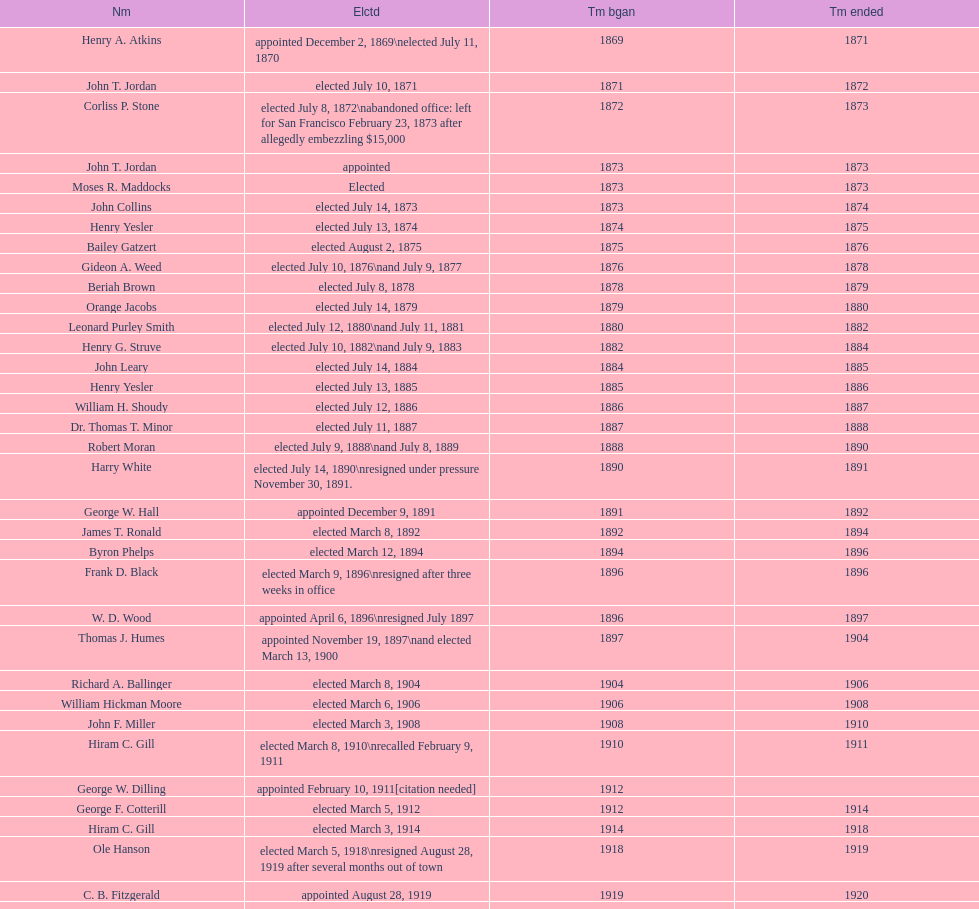Who began their term in 1890? Harry White. I'm looking to parse the entire table for insights. Could you assist me with that? {'header': ['Nm', 'Elctd', 'Tm bgan', 'Tm ended'], 'rows': [['Henry A. Atkins', 'appointed December 2, 1869\\nelected July 11, 1870', '1869', '1871'], ['John T. Jordan', 'elected July 10, 1871', '1871', '1872'], ['Corliss P. Stone', 'elected July 8, 1872\\nabandoned office: left for San Francisco February 23, 1873 after allegedly embezzling $15,000', '1872', '1873'], ['John T. Jordan', 'appointed', '1873', '1873'], ['Moses R. Maddocks', 'Elected', '1873', '1873'], ['John Collins', 'elected July 14, 1873', '1873', '1874'], ['Henry Yesler', 'elected July 13, 1874', '1874', '1875'], ['Bailey Gatzert', 'elected August 2, 1875', '1875', '1876'], ['Gideon A. Weed', 'elected July 10, 1876\\nand July 9, 1877', '1876', '1878'], ['Beriah Brown', 'elected July 8, 1878', '1878', '1879'], ['Orange Jacobs', 'elected July 14, 1879', '1879', '1880'], ['Leonard Purley Smith', 'elected July 12, 1880\\nand July 11, 1881', '1880', '1882'], ['Henry G. Struve', 'elected July 10, 1882\\nand July 9, 1883', '1882', '1884'], ['John Leary', 'elected July 14, 1884', '1884', '1885'], ['Henry Yesler', 'elected July 13, 1885', '1885', '1886'], ['William H. Shoudy', 'elected July 12, 1886', '1886', '1887'], ['Dr. Thomas T. Minor', 'elected July 11, 1887', '1887', '1888'], ['Robert Moran', 'elected July 9, 1888\\nand July 8, 1889', '1888', '1890'], ['Harry White', 'elected July 14, 1890\\nresigned under pressure November 30, 1891.', '1890', '1891'], ['George W. Hall', 'appointed December 9, 1891', '1891', '1892'], ['James T. Ronald', 'elected March 8, 1892', '1892', '1894'], ['Byron Phelps', 'elected March 12, 1894', '1894', '1896'], ['Frank D. Black', 'elected March 9, 1896\\nresigned after three weeks in office', '1896', '1896'], ['W. D. Wood', 'appointed April 6, 1896\\nresigned July 1897', '1896', '1897'], ['Thomas J. Humes', 'appointed November 19, 1897\\nand elected March 13, 1900', '1897', '1904'], ['Richard A. Ballinger', 'elected March 8, 1904', '1904', '1906'], ['William Hickman Moore', 'elected March 6, 1906', '1906', '1908'], ['John F. Miller', 'elected March 3, 1908', '1908', '1910'], ['Hiram C. Gill', 'elected March 8, 1910\\nrecalled February 9, 1911', '1910', '1911'], ['George W. Dilling', 'appointed February 10, 1911[citation needed]', '1912', ''], ['George F. Cotterill', 'elected March 5, 1912', '1912', '1914'], ['Hiram C. Gill', 'elected March 3, 1914', '1914', '1918'], ['Ole Hanson', 'elected March 5, 1918\\nresigned August 28, 1919 after several months out of town', '1918', '1919'], ['C. B. Fitzgerald', 'appointed August 28, 1919', '1919', '1920'], ['Hugh M. Caldwell', 'elected March 2, 1920', '1920', '1922'], ['Edwin J. Brown', 'elected May 2, 1922\\nand March 4, 1924', '1922', '1926'], ['Bertha Knight Landes', 'elected March 9, 1926', '1926', '1928'], ['Frank E. Edwards', 'elected March 6, 1928\\nand March 4, 1930\\nrecalled July 13, 1931', '1928', '1931'], ['Robert H. Harlin', 'appointed July 14, 1931', '1931', '1932'], ['John F. Dore', 'elected March 8, 1932', '1932', '1934'], ['Charles L. Smith', 'elected March 6, 1934', '1934', '1936'], ['John F. Dore', 'elected March 3, 1936\\nbecame gravely ill and was relieved of office April 13, 1938, already a lame duck after the 1938 election. He died five days later.', '1936', '1938'], ['Arthur B. Langlie', "elected March 8, 1938\\nappointed to take office early, April 27, 1938, after Dore's death.\\nelected March 5, 1940\\nresigned January 11, 1941, to become Governor of Washington", '1938', '1941'], ['John E. Carroll', 'appointed January 27, 1941', '1941', '1941'], ['Earl Millikin', 'elected March 4, 1941', '1941', '1942'], ['William F. Devin', 'elected March 3, 1942, March 7, 1944, March 5, 1946, and March 2, 1948', '1942', '1952'], ['Allan Pomeroy', 'elected March 4, 1952', '1952', '1956'], ['Gordon S. Clinton', 'elected March 6, 1956\\nand March 8, 1960', '1956', '1964'], ["James d'Orma Braman", 'elected March 10, 1964\\nresigned March 23, 1969, to accept an appointment as an Assistant Secretary in the Department of Transportation in the Nixon administration.', '1964', '1969'], ['Floyd C. Miller', 'appointed March 23, 1969', '1969', '1969'], ['Wesley C. Uhlman', 'elected November 4, 1969\\nand November 6, 1973\\nsurvived recall attempt on July 1, 1975', 'December 1, 1969', 'January 1, 1978'], ['Charles Royer', 'elected November 8, 1977, November 3, 1981, and November 5, 1985', 'January 1, 1978', 'January 1, 1990'], ['Norman B. Rice', 'elected November 7, 1989', 'January 1, 1990', 'January 1, 1998'], ['Paul Schell', 'elected November 4, 1997', 'January 1, 1998', 'January 1, 2002'], ['Gregory J. Nickels', 'elected November 6, 2001\\nand November 8, 2005', 'January 1, 2002', 'January 1, 2010'], ['Michael McGinn', 'elected November 3, 2009', 'January 1, 2010', 'January 1, 2014'], ['Ed Murray', 'elected November 5, 2013', 'January 1, 2014', 'present']]} 